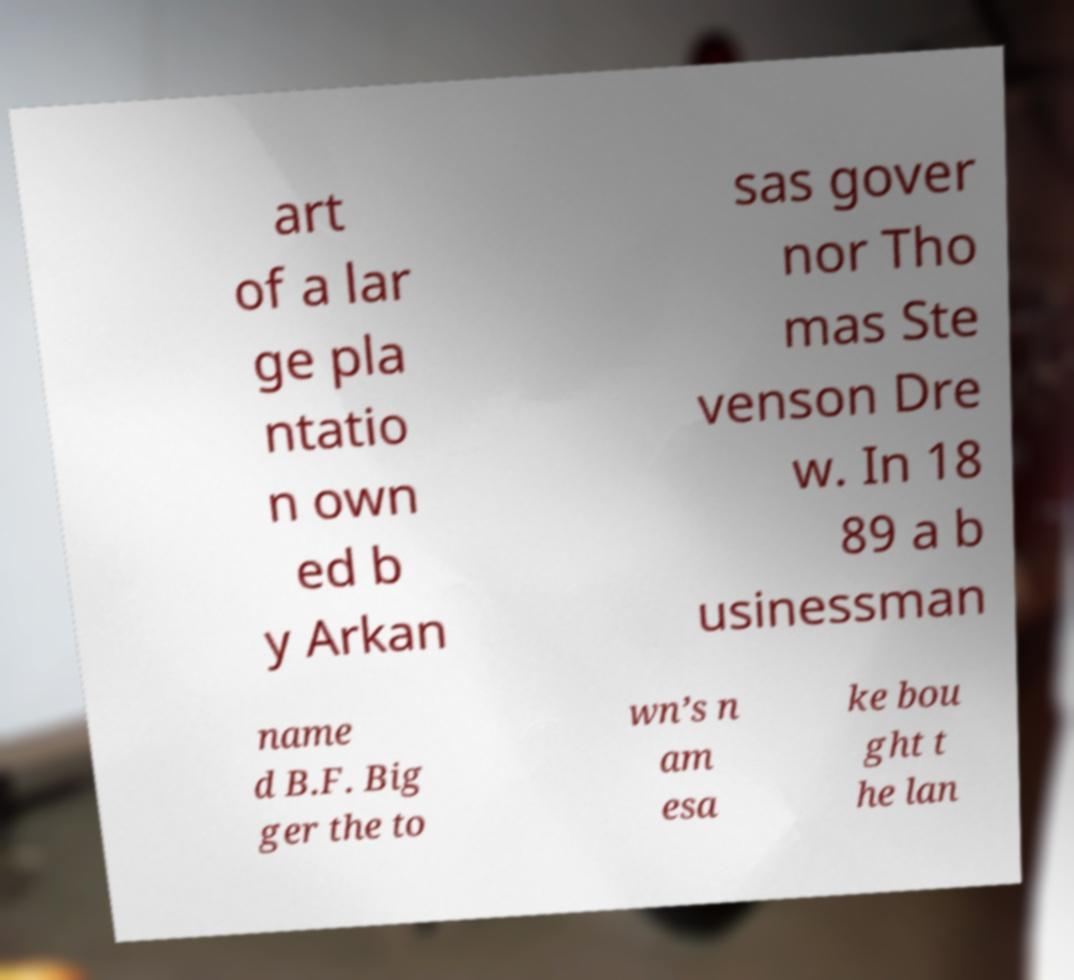There's text embedded in this image that I need extracted. Can you transcribe it verbatim? art of a lar ge pla ntatio n own ed b y Arkan sas gover nor Tho mas Ste venson Dre w. In 18 89 a b usinessman name d B.F. Big ger the to wn’s n am esa ke bou ght t he lan 